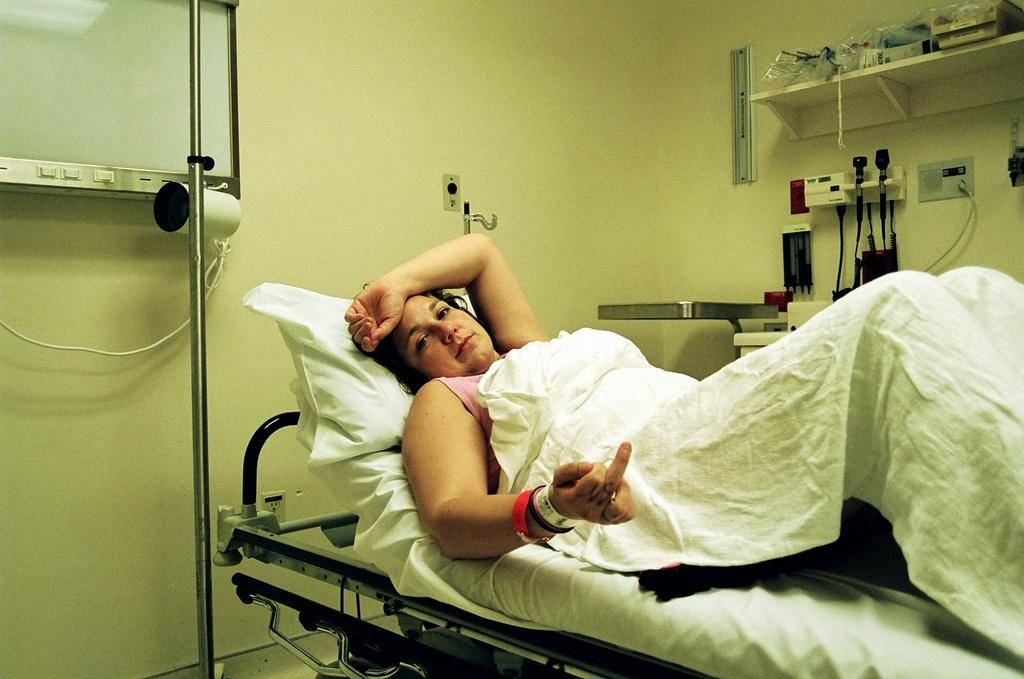What is the person in the image doing on the bed? The person is lying on the bed in the image. What is the person doing with their finger? The person is showing their finger in the image. What is on the bed besides the person? A pillow is present on the bed. What can be seen in the background of the image? There is a stand, a wall, and machines visible in the background of the image. What type of haircut is the baby getting in the image? There is no baby present in the image, and therefore no haircut can be observed. 